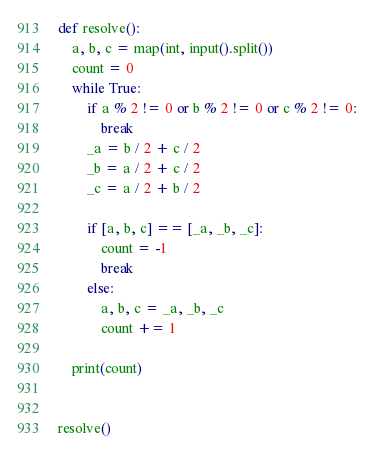<code> <loc_0><loc_0><loc_500><loc_500><_Python_>def resolve():
    a, b, c = map(int, input().split())
    count = 0
    while True:
        if a % 2 != 0 or b % 2 != 0 or c % 2 != 0:
            break
        _a = b / 2 + c / 2
        _b = a / 2 + c / 2
        _c = a / 2 + b / 2

        if [a, b, c] == [_a, _b, _c]:
            count = -1
            break
        else:
            a, b, c = _a, _b, _c
            count += 1

    print(count)


resolve()</code> 